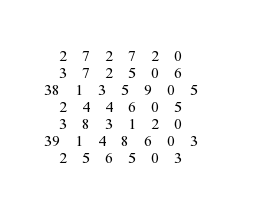<code> <loc_0><loc_0><loc_500><loc_500><_ObjectiveC_>	2	7	2	7	2	0	
	3	7	2	5	0	6	
38	1	3	5	9	0	5	
	2	4	4	6	0	5	
	3	8	3	1	2	0	
39	1	4	8	6	0	3	
	2	5	6	5	0	3	</code> 